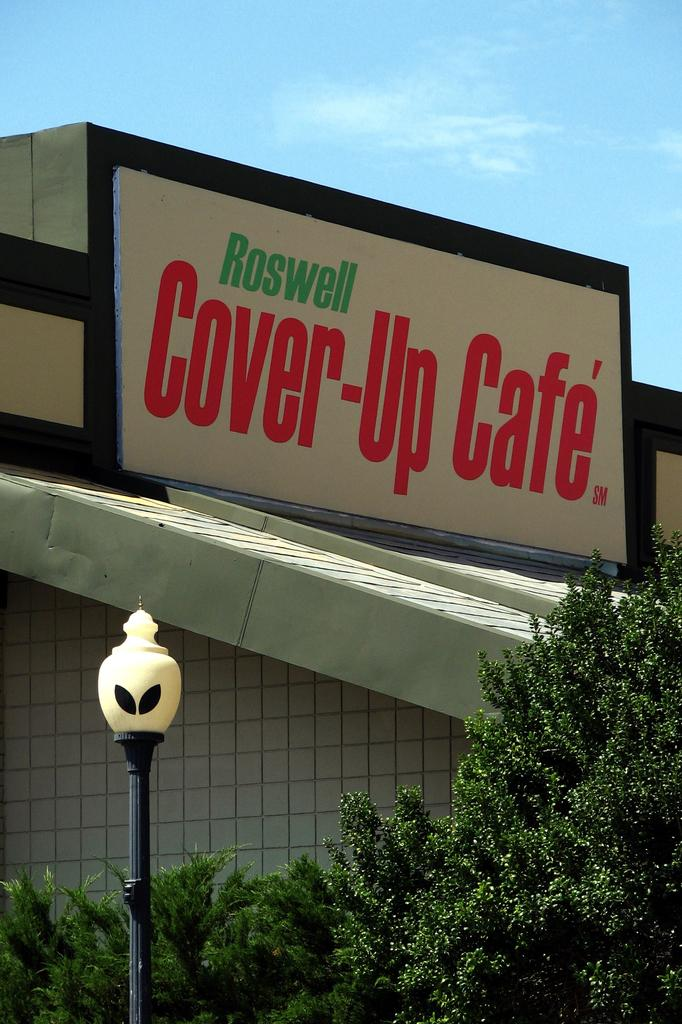What is written on the board in the image? The facts do not specify the text on the board, so we cannot answer this question definitively. What type of plants are in the image? The facts do not specify the type of plants, so we cannot answer this question definitively. What is the pole used for in the image? The facts do not specify the purpose of the pole, so we cannot answer this question definitively. What is the fence made of in the image? The facts do not specify the material of the fence, so we cannot answer this question definitively. What is the color of the sky in the image? The facts do not specify the color of the sky, so we cannot answer this question definitively. How many cubs are playing with the screws in the image? There are no cubs or screws present in the image. Does the existence of the board in the image prove the existence of the universe? The presence of the board in the image does not prove the existence of the universe, as the board is a small part of a larger scene. 